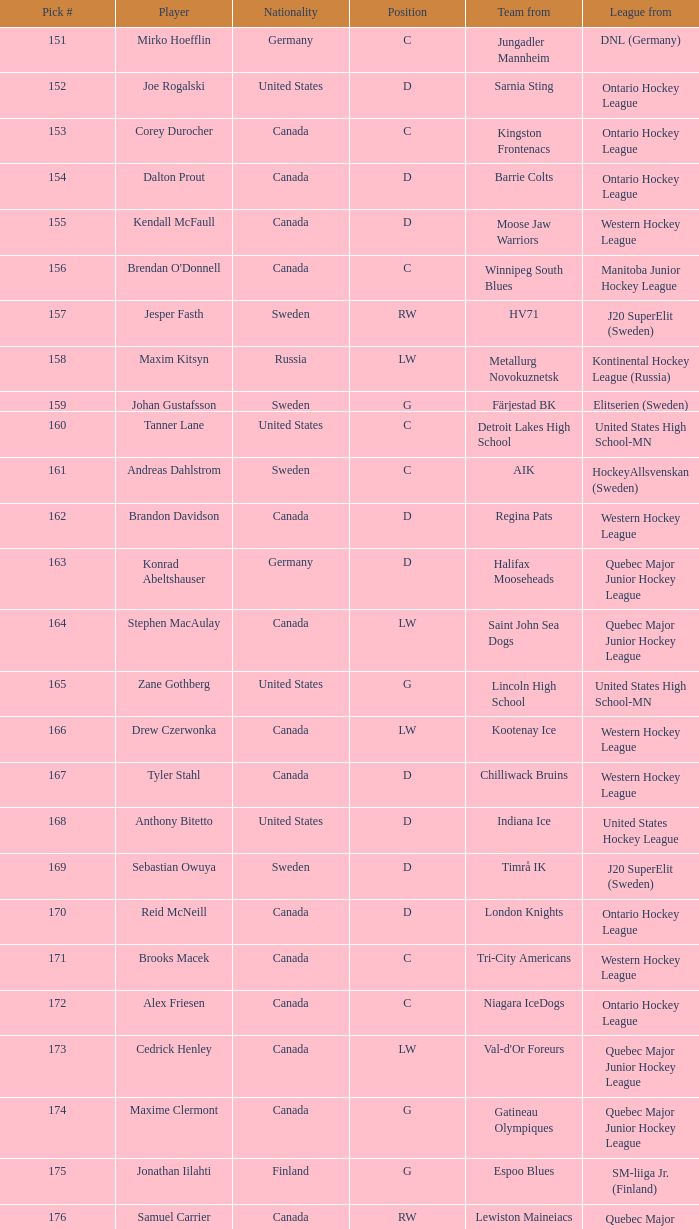What is the cumulative draft pick for the d position in the chilliwack bruins team? 167.0. 